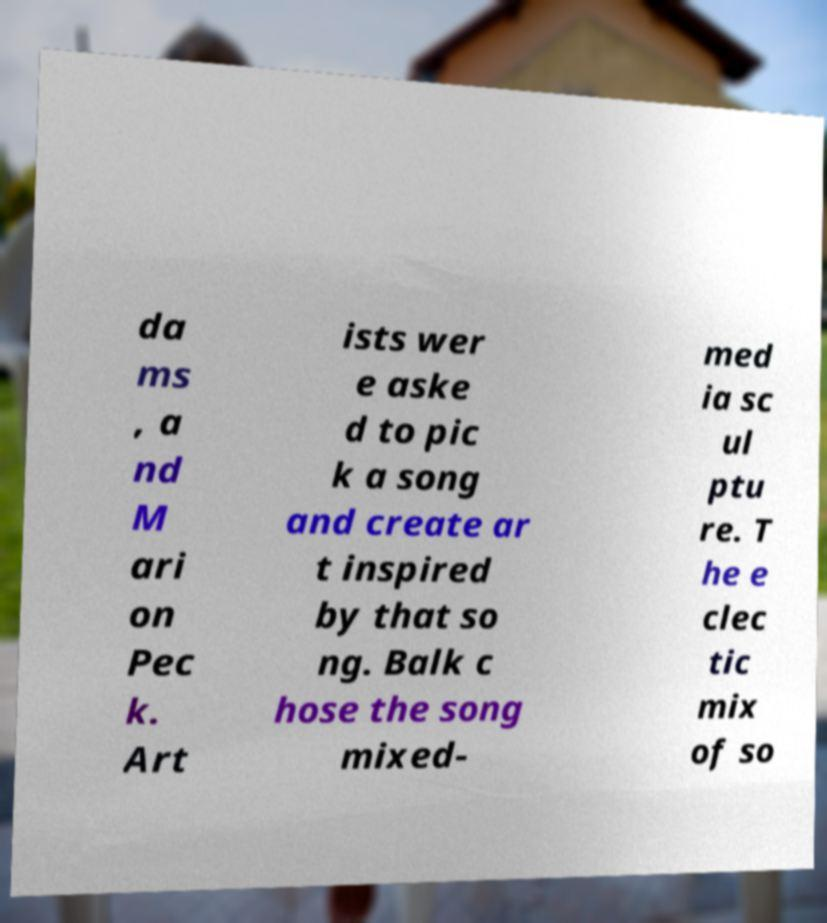Please read and relay the text visible in this image. What does it say? da ms , a nd M ari on Pec k. Art ists wer e aske d to pic k a song and create ar t inspired by that so ng. Balk c hose the song mixed- med ia sc ul ptu re. T he e clec tic mix of so 